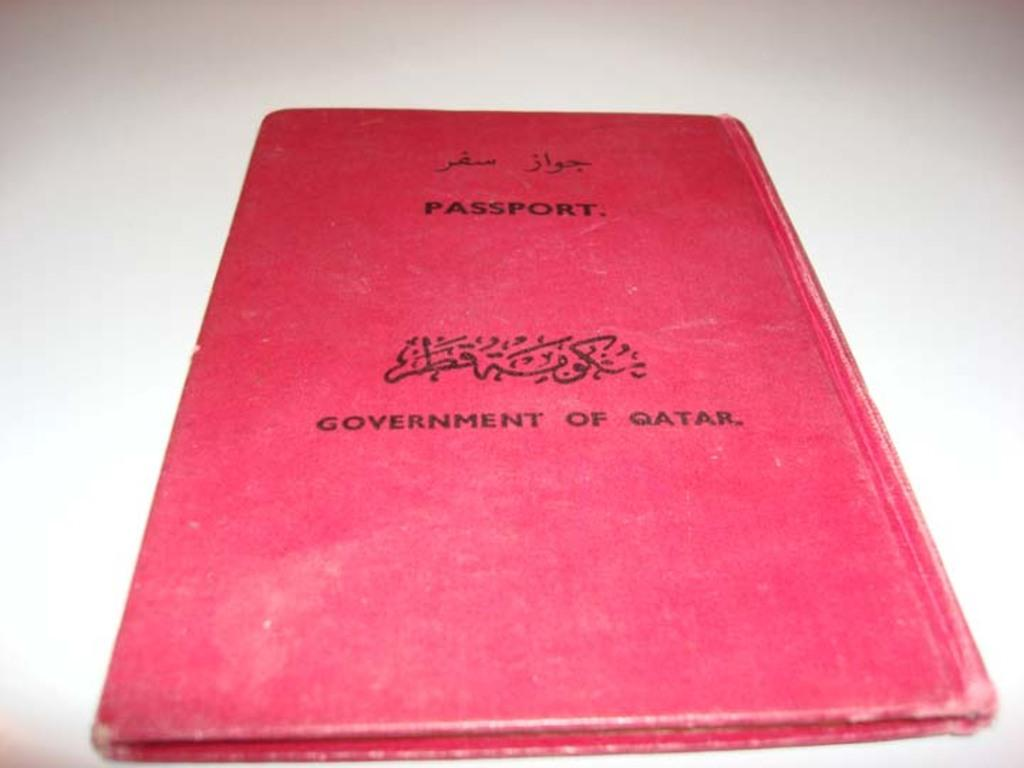Provide a one-sentence caption for the provided image. A red passport issued by the government of Qatar. 